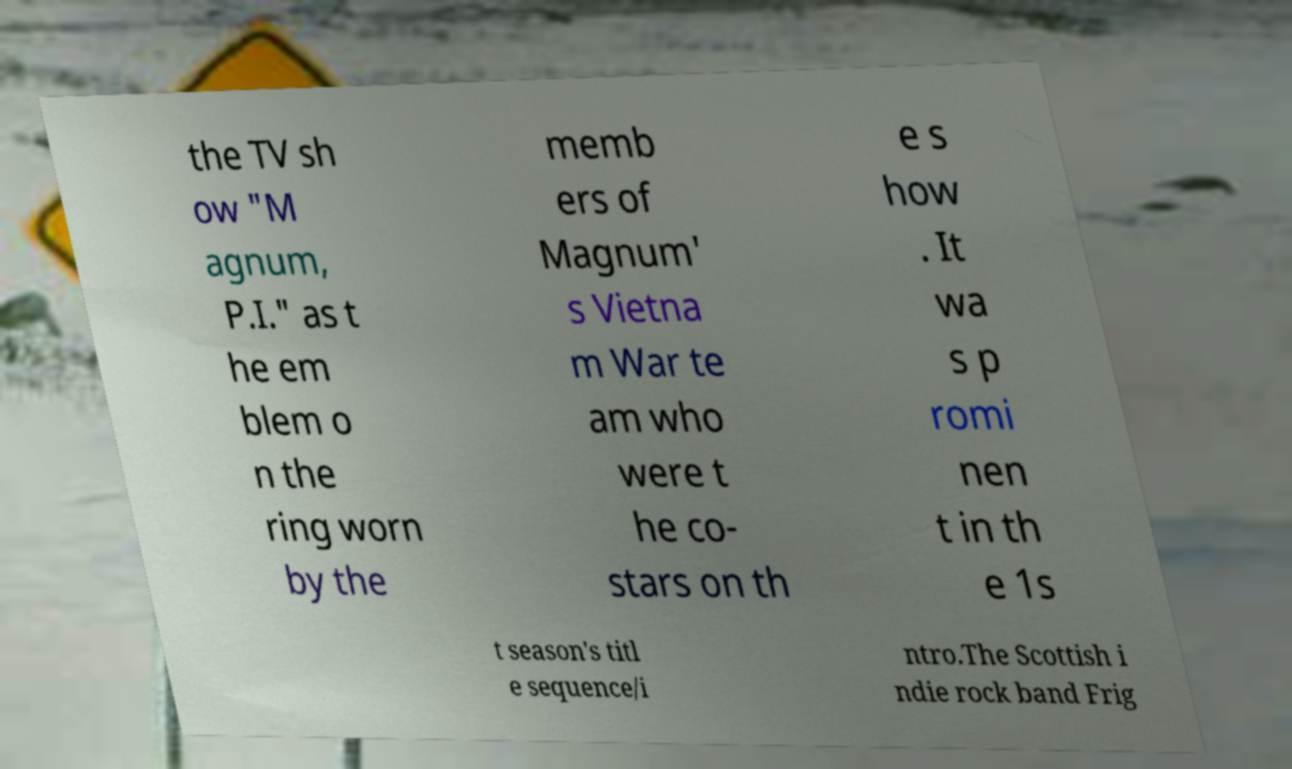Can you accurately transcribe the text from the provided image for me? the TV sh ow "M agnum, P.I." as t he em blem o n the ring worn by the memb ers of Magnum' s Vietna m War te am who were t he co- stars on th e s how . It wa s p romi nen t in th e 1s t season's titl e sequence/i ntro.The Scottish i ndie rock band Frig 